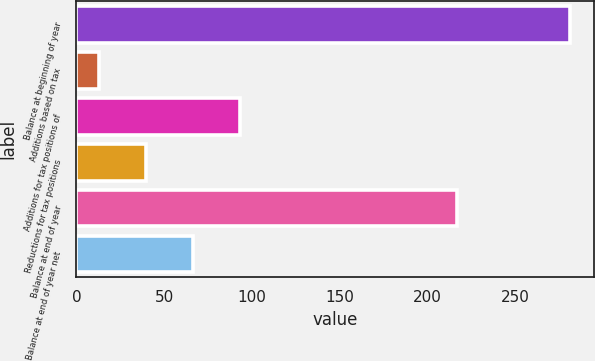<chart> <loc_0><loc_0><loc_500><loc_500><bar_chart><fcel>Balance at beginning of year<fcel>Additions based on tax<fcel>Additions for tax positions of<fcel>Reductions for tax positions<fcel>Balance at end of year<fcel>Balance at end of year net<nl><fcel>281<fcel>13<fcel>93.4<fcel>39.8<fcel>217<fcel>66.6<nl></chart> 